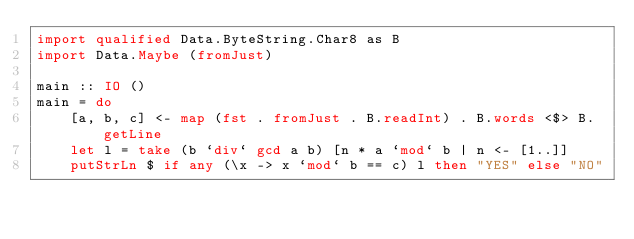Convert code to text. <code><loc_0><loc_0><loc_500><loc_500><_Haskell_>import qualified Data.ByteString.Char8 as B
import Data.Maybe (fromJust)

main :: IO ()
main = do
    [a, b, c] <- map (fst . fromJust . B.readInt) . B.words <$> B.getLine
    let l = take (b `div` gcd a b) [n * a `mod` b | n <- [1..]]
    putStrLn $ if any (\x -> x `mod` b == c) l then "YES" else "NO"
</code> 